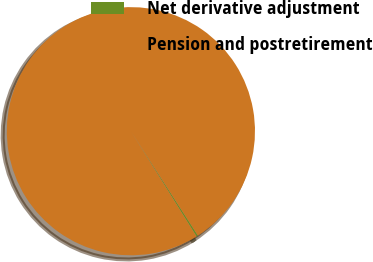Convert chart to OTSL. <chart><loc_0><loc_0><loc_500><loc_500><pie_chart><fcel>Net derivative adjustment<fcel>Pension and postretirement<nl><fcel>0.22%<fcel>99.78%<nl></chart> 